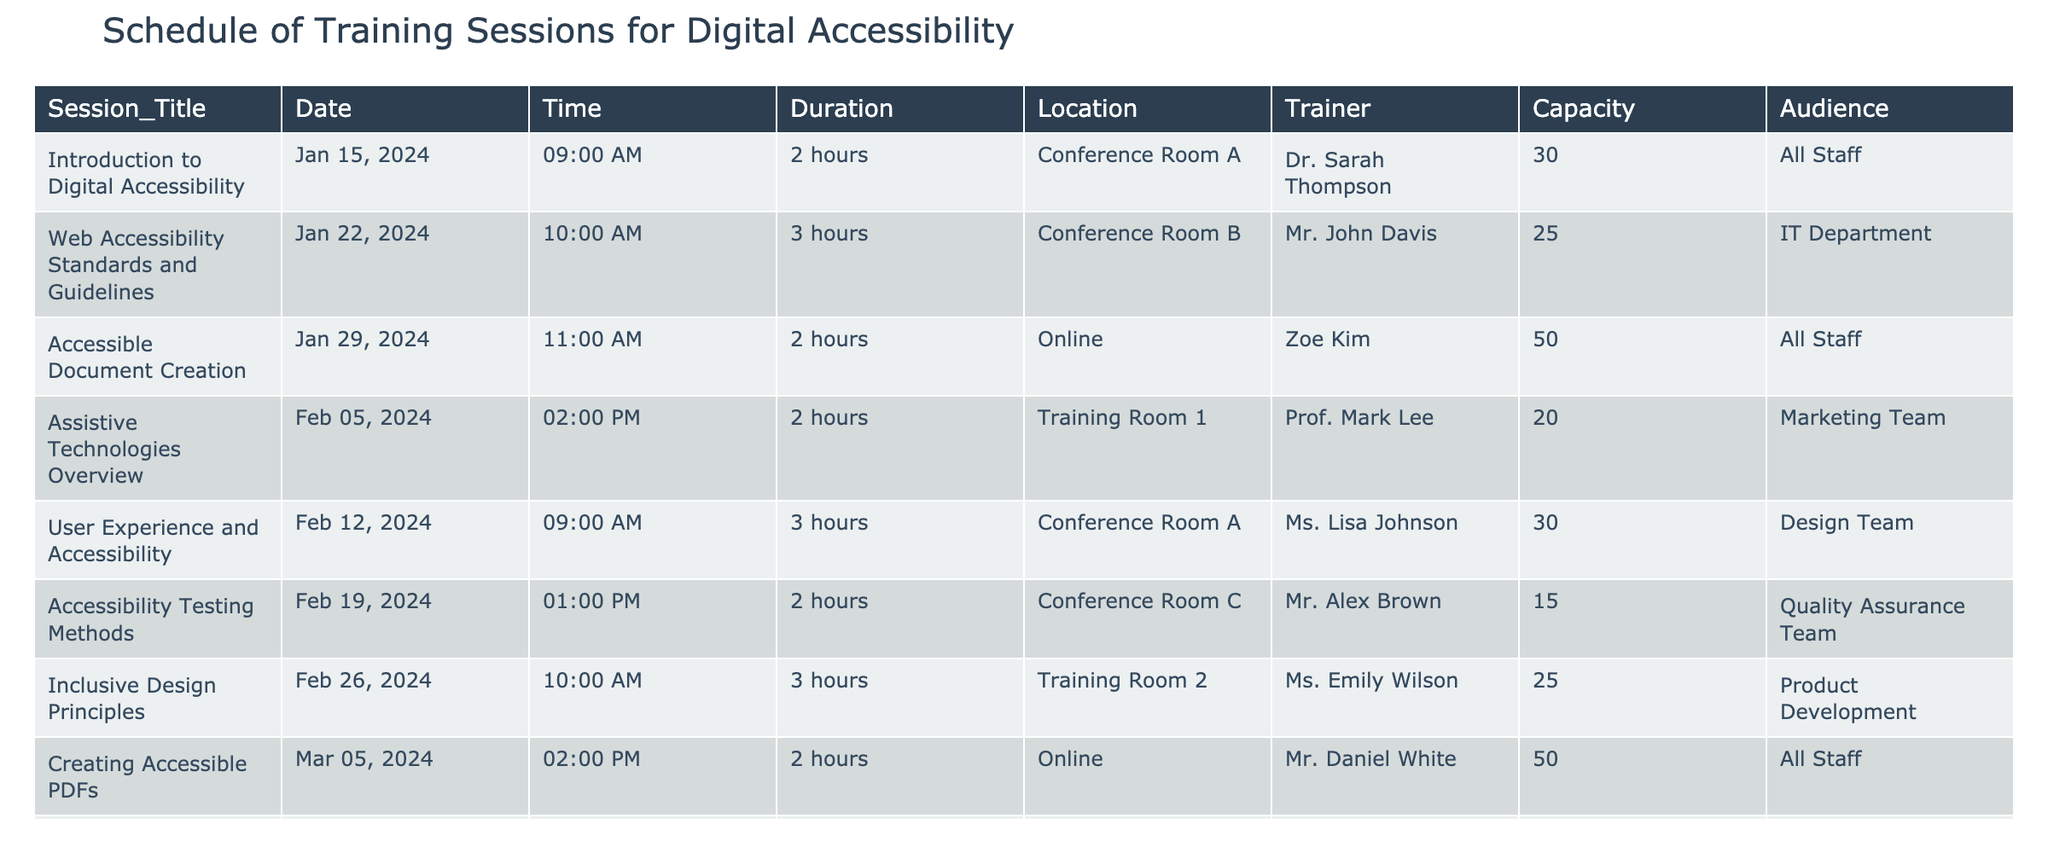What is the title of the second training session? The second training session listed in the table is titled "Web Accessibility Standards and Guidelines" as it appears in the Session_Title column at the second row.
Answer: Web Accessibility Standards and Guidelines Which training session is scheduled for February 5, 2024? The training session scheduled for February 5, 2024, is "Assistive Technologies Overview," according to the Date column and corresponding Session_Title.
Answer: Assistive Technologies Overview How many hours is the "Creating Accessible PDFs" session? The "Creating Accessible PDFs" session has a duration of 2 hours, which is indicated in the Duration column for that session's row.
Answer: 2 hours Is there a session targeting the Communications Team? Yes, there is a session titled "Accessibility in Social Media" planned for the Communications Team, as shown in the Audience column for that session.
Answer: Yes What is the capacity of the session "Advanced Accessibility Features"? The capacity for "Advanced Accessibility Features" is 15, as listed in the Capacity column for that session entry.
Answer: 15 How many total hours are dedicated to training sessions scheduled for January and February? The sessions in January and February are: "Introduction to Digital Accessibility" (2 hours), "Web Accessibility Standards and Guidelines" (3 hours), "Accessible Document Creation" (2 hours), "Assistive Technologies Overview" (2 hours), "User Experience and Accessibility" (3 hours), "Accessibility Testing Methods" (2 hours), and "Inclusive Design Principles" (3 hours). Adding these gives 2 + 3 + 2 + 2 + 3 + 2 + 3 = 17 hours total.
Answer: 17 hours Which trainer is conducting the session with the highest number of participants? By comparing the capacity values, the "Accessible Document Creation" session has the highest capacity of 50 participants, taught by Zoe Kim.
Answer: Zoe Kim How many sessions are scheduled for the IT Department? There are two sessions scheduled for the IT Department: "Web Accessibility Standards and Guidelines" and "Advanced Accessibility Features," according to the Audience column.
Answer: 2 sessions Which training session has the shortest duration, and what is that duration? The session with the shortest duration is "Accessibility in Social Media," which lasts 1.5 hours. This is directly reflected in the Duration column for that session.
Answer: 1.5 hours 